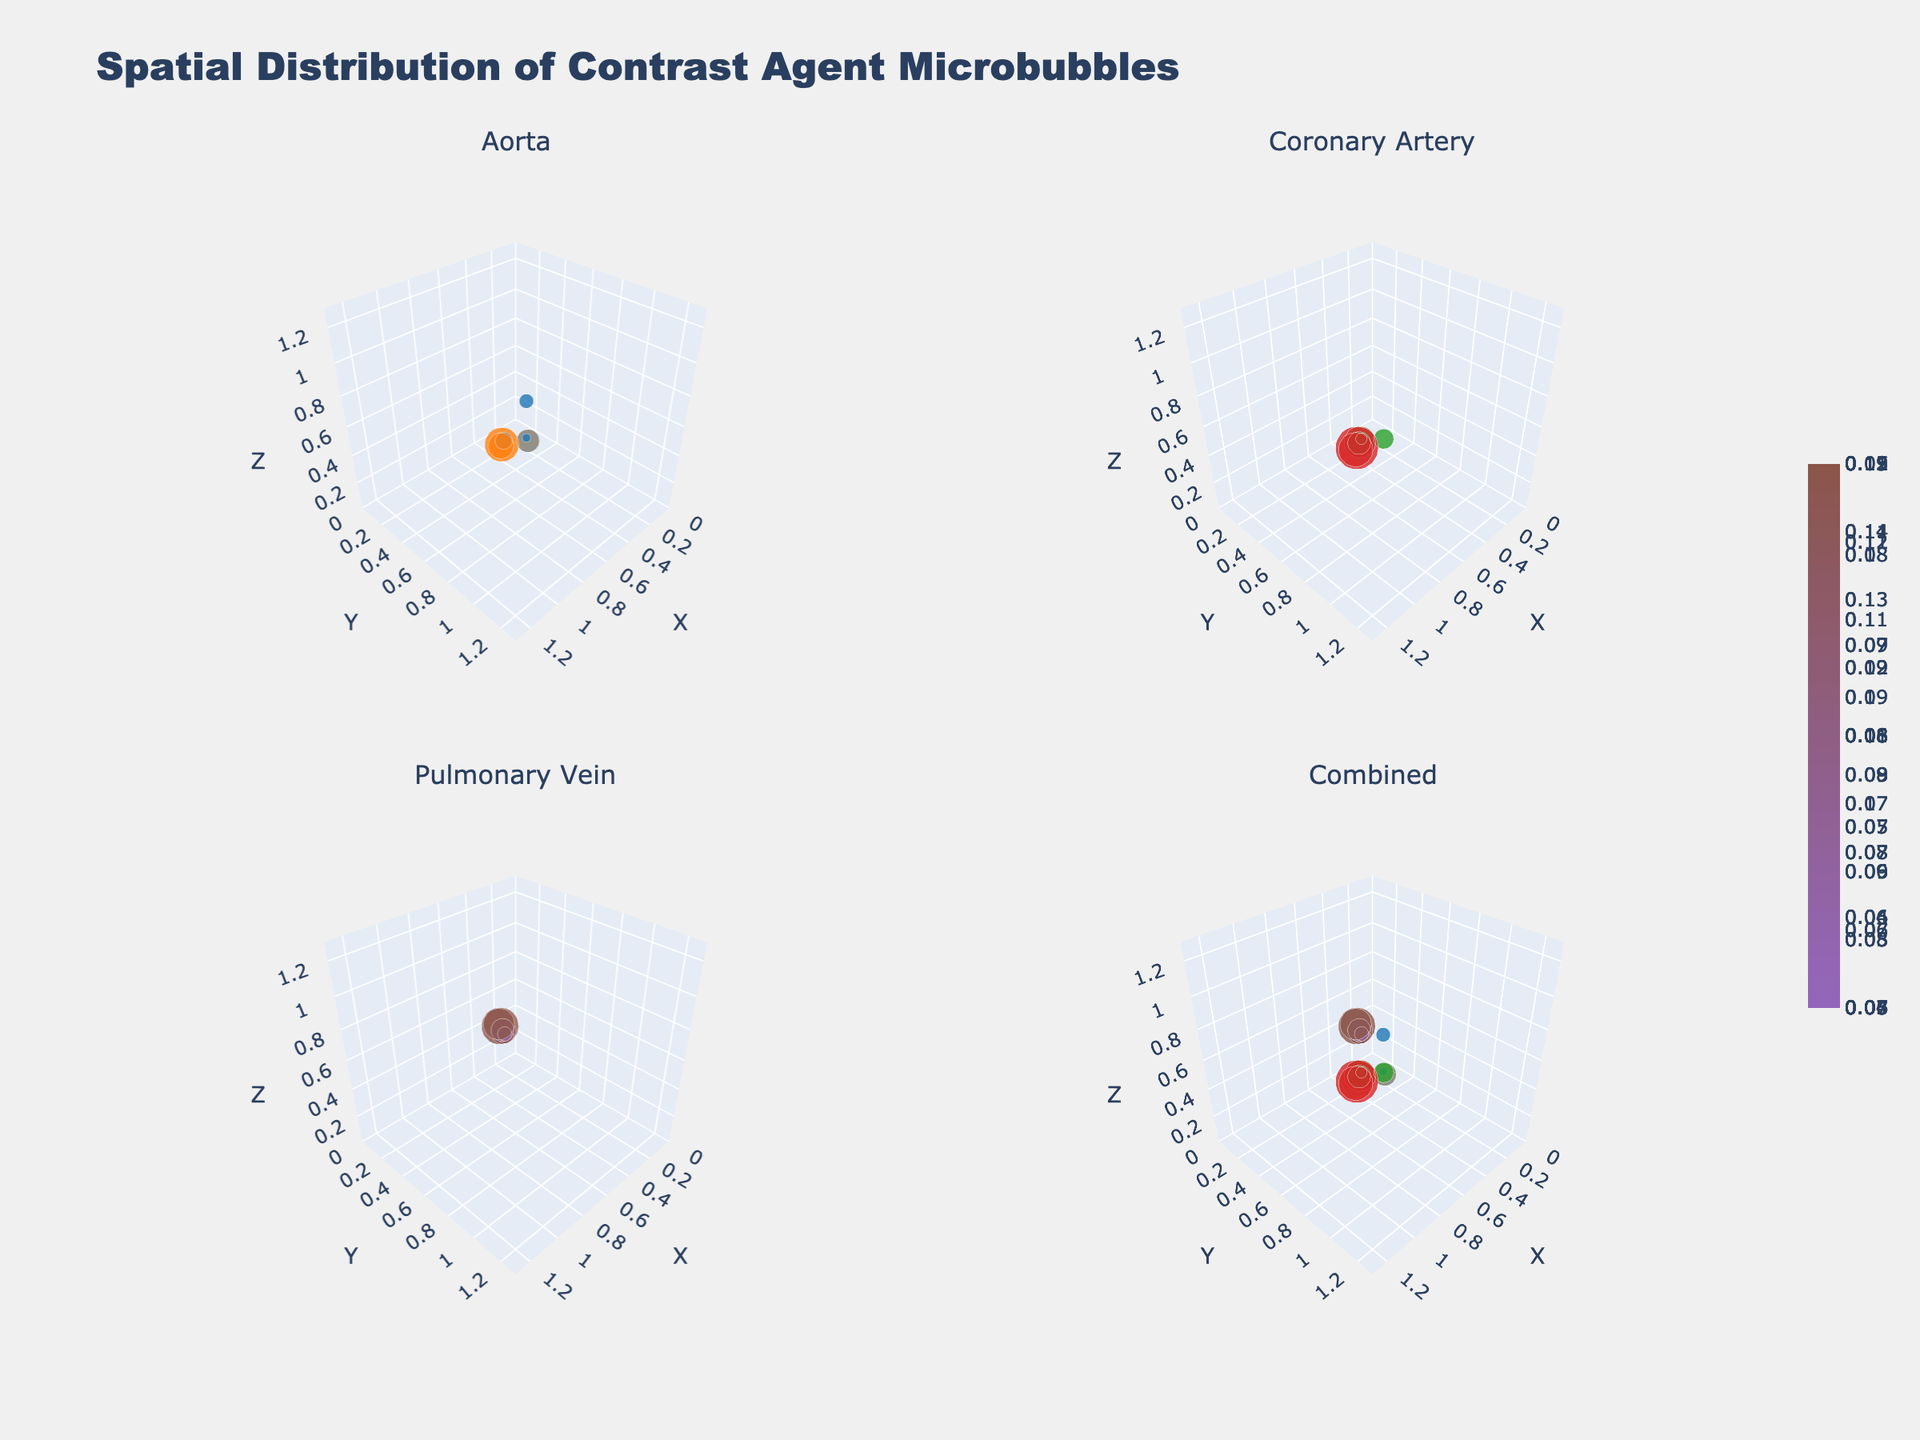what is the title of the figure? The title of the figure is displayed at the top of the plot. It reads "Spatial Distribution of Contrast Agent Microbubbles". This can be directly read off the plot without any need for deeper analysis.
Answer: Spatial Distribution of Contrast Agent Microbubbles What are the names of the vessels shown in the subplots? The subplot titles mention the names of the vessels, which are "Aorta", "Coronary Artery", and "Pulmonary Vein". There is also a subplot titled "Combined" which includes data from all vessels.
Answer: Aorta, Coronary Artery, Pulmonary Vein Which vessel exhibits the highest concentration of microbubbles during the Systole phase? The plot indicates the concentration of microbubbles via the size and color intensity of the markers. By observing the subplot for each vessel during the Systole phase, we can see that the Coronary Artery has the highest concentration of microbubbles, indicated by larger and more intensely colored markers compared to the Aorta and Pulmonary Vein.
Answer: Coronary Artery How does the average concentration of microbubbles change from Systole to Diastole in the Aorta? By inspecting the sizes and color intensities of the markers in the Aorta subplot during Systole and Diastole, it is evident that the average size and color intensity of markers is lower in Diastole than in Systole, indicating a decrease in the concentration of microbubbles from Systole to Diastole.
Answer: Decreases Which phase shows more even distribution of microbubbles in the Pulmonary Vein? Observing the distribution of the markers in the Pulmonary Vein subplot, during Diastole, the microbubbles appear more evenly spread out, with similar sizes and color intensities indicating consistent concentrations throughout the vessel. In contrast, Systole shows more variance in marker sizes and intensities.
Answer: Diastole How do the spatial distributions of microbubbles in the Coronary Artery compare between Systole and Diastole? In the Coronary Artery subplot, during Systole, the markers are larger and more brightly colored, indicating higher concentrations of microbubbles. During Diastole, the markers are smaller and less intensely colored, showing a lower concentration. The spatial spread appears somewhat similar in both phases, but the concentration is higher in Systole.
Answer: Higher concentration in Systole, similar spatial spread Which subplot combines data from all vessels, and what trends can be observed in it? The subplot titled "Combined" compiles data from the Aorta, Coronary Artery, and Pulmonary Vein. Trends that can be observed include the general clustering pattern of microbubble concentrations, where more intense clusters are visible during Systole across all vessels, particularly in the Coronary Artery. This provides an overview of microbubble distributions across all vessels and phases.
Answer: Combined, higher concentrations during Systole 